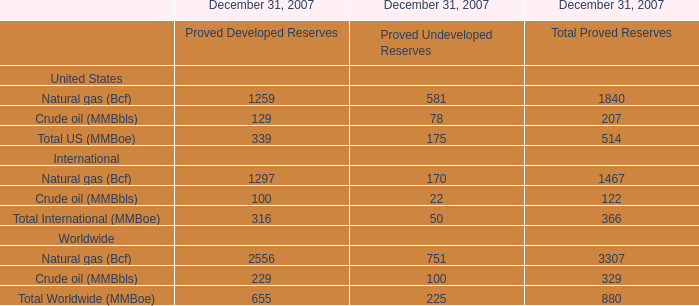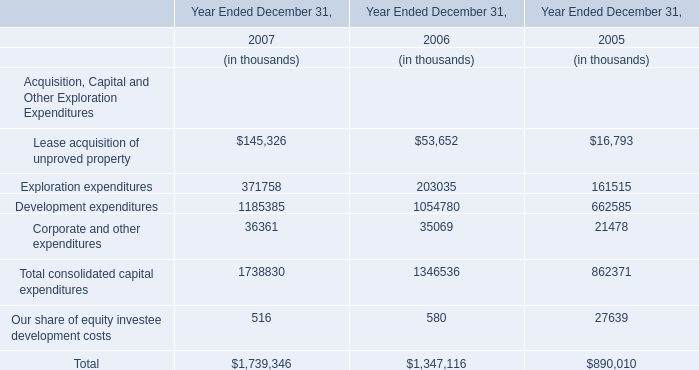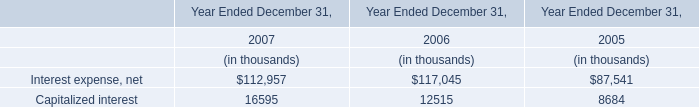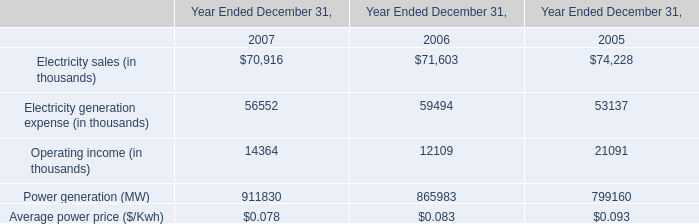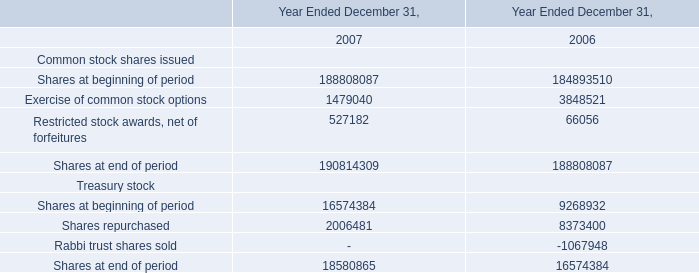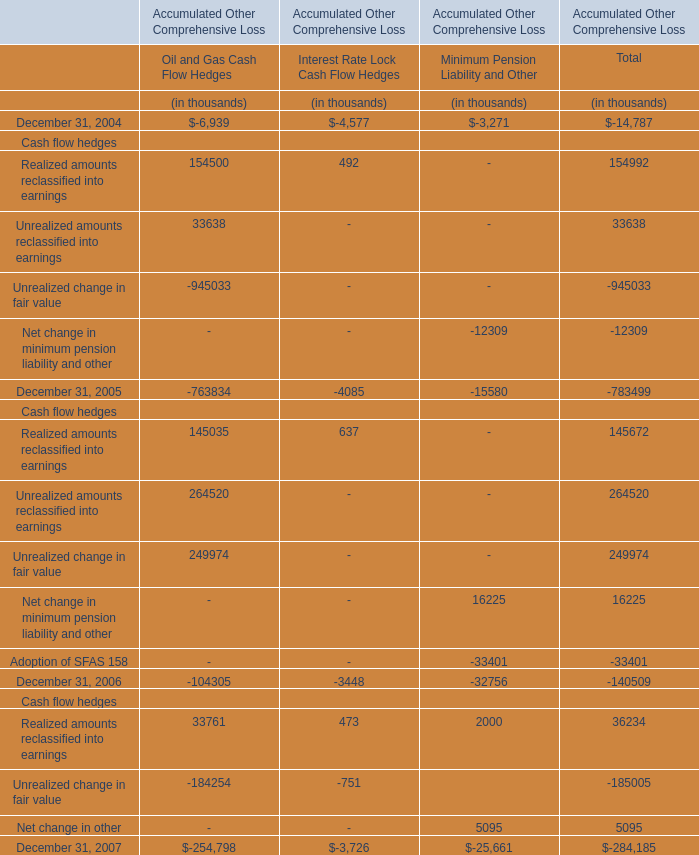Does the proportion ofOil and Gas Cash Flow Hedges in total larger than that of Minimum Pension Liability and Other in 2004? 
Answer: yes. 